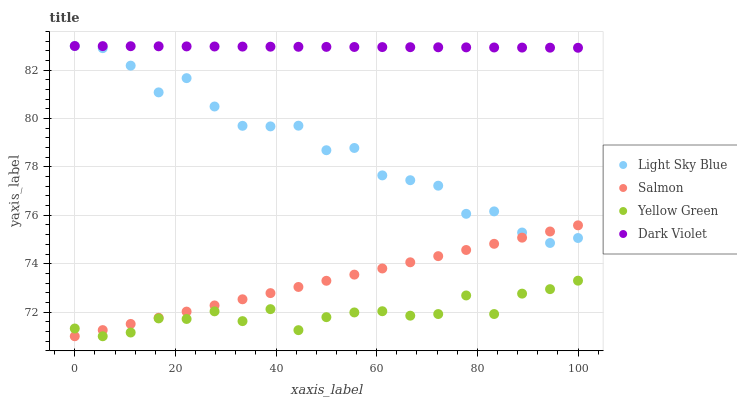Does Yellow Green have the minimum area under the curve?
Answer yes or no. Yes. Does Dark Violet have the maximum area under the curve?
Answer yes or no. Yes. Does Salmon have the minimum area under the curve?
Answer yes or no. No. Does Salmon have the maximum area under the curve?
Answer yes or no. No. Is Salmon the smoothest?
Answer yes or no. Yes. Is Light Sky Blue the roughest?
Answer yes or no. Yes. Is Yellow Green the smoothest?
Answer yes or no. No. Is Yellow Green the roughest?
Answer yes or no. No. Does Salmon have the lowest value?
Answer yes or no. Yes. Does Dark Violet have the lowest value?
Answer yes or no. No. Does Dark Violet have the highest value?
Answer yes or no. Yes. Does Salmon have the highest value?
Answer yes or no. No. Is Yellow Green less than Light Sky Blue?
Answer yes or no. Yes. Is Dark Violet greater than Yellow Green?
Answer yes or no. Yes. Does Salmon intersect Light Sky Blue?
Answer yes or no. Yes. Is Salmon less than Light Sky Blue?
Answer yes or no. No. Is Salmon greater than Light Sky Blue?
Answer yes or no. No. Does Yellow Green intersect Light Sky Blue?
Answer yes or no. No. 